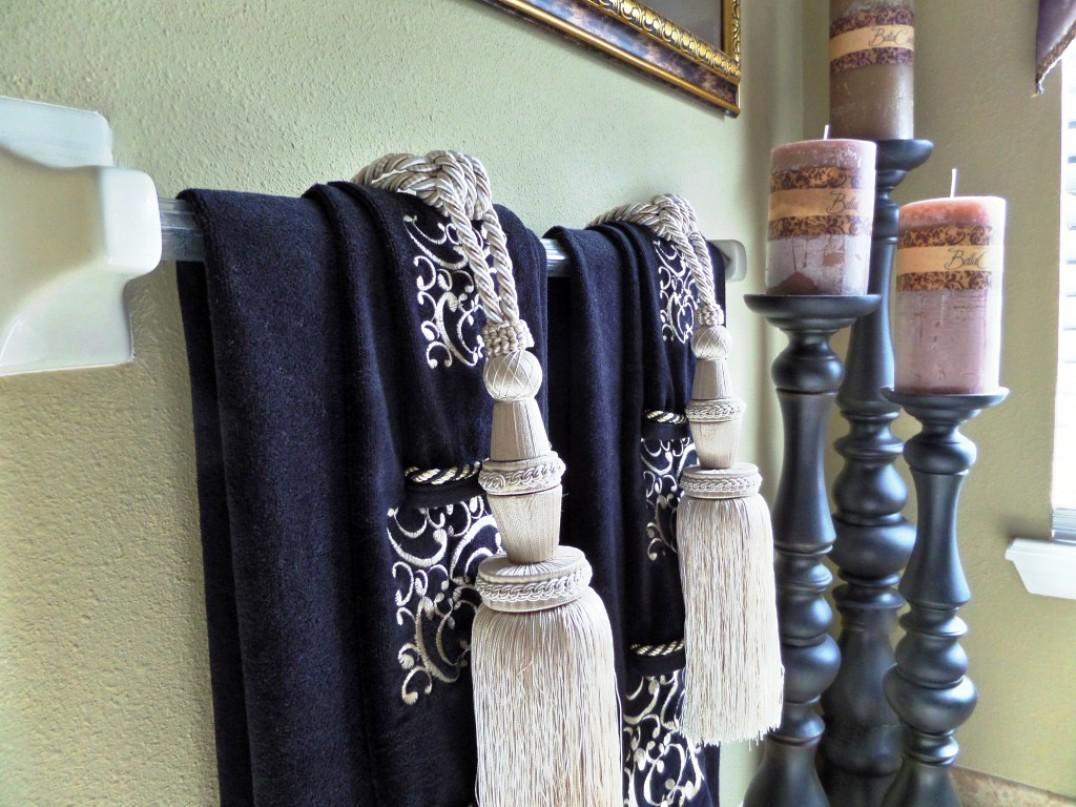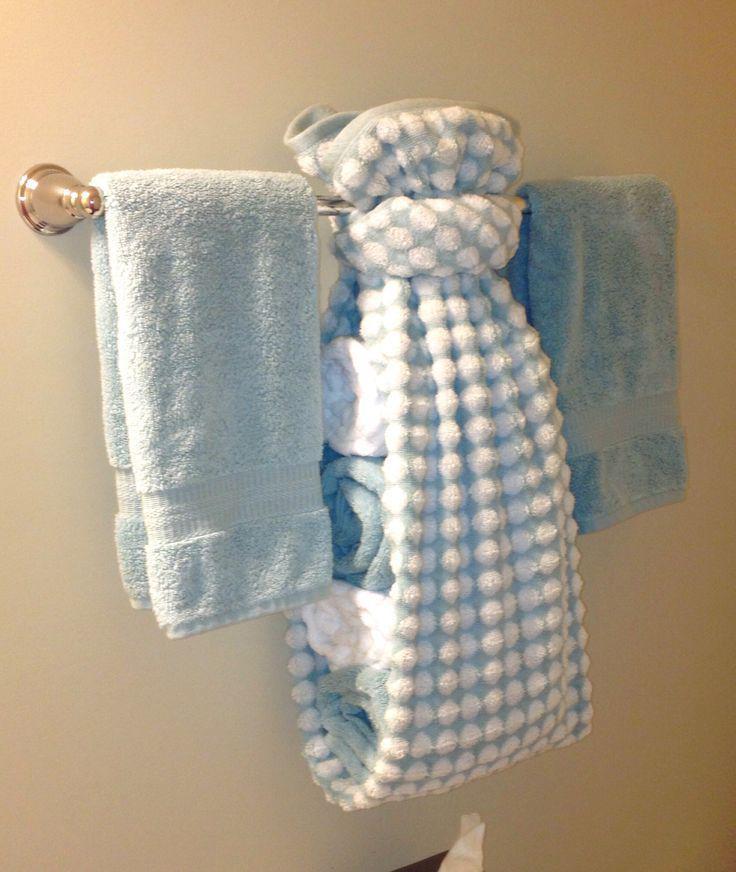The first image is the image on the left, the second image is the image on the right. Considering the images on both sides, is "The left and right image contains the same number of rows of tie towels." valid? Answer yes or no. No. 